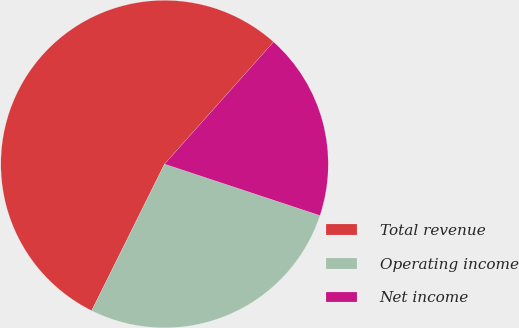Convert chart. <chart><loc_0><loc_0><loc_500><loc_500><pie_chart><fcel>Total revenue<fcel>Operating income<fcel>Net income<nl><fcel>54.26%<fcel>27.25%<fcel>18.49%<nl></chart> 